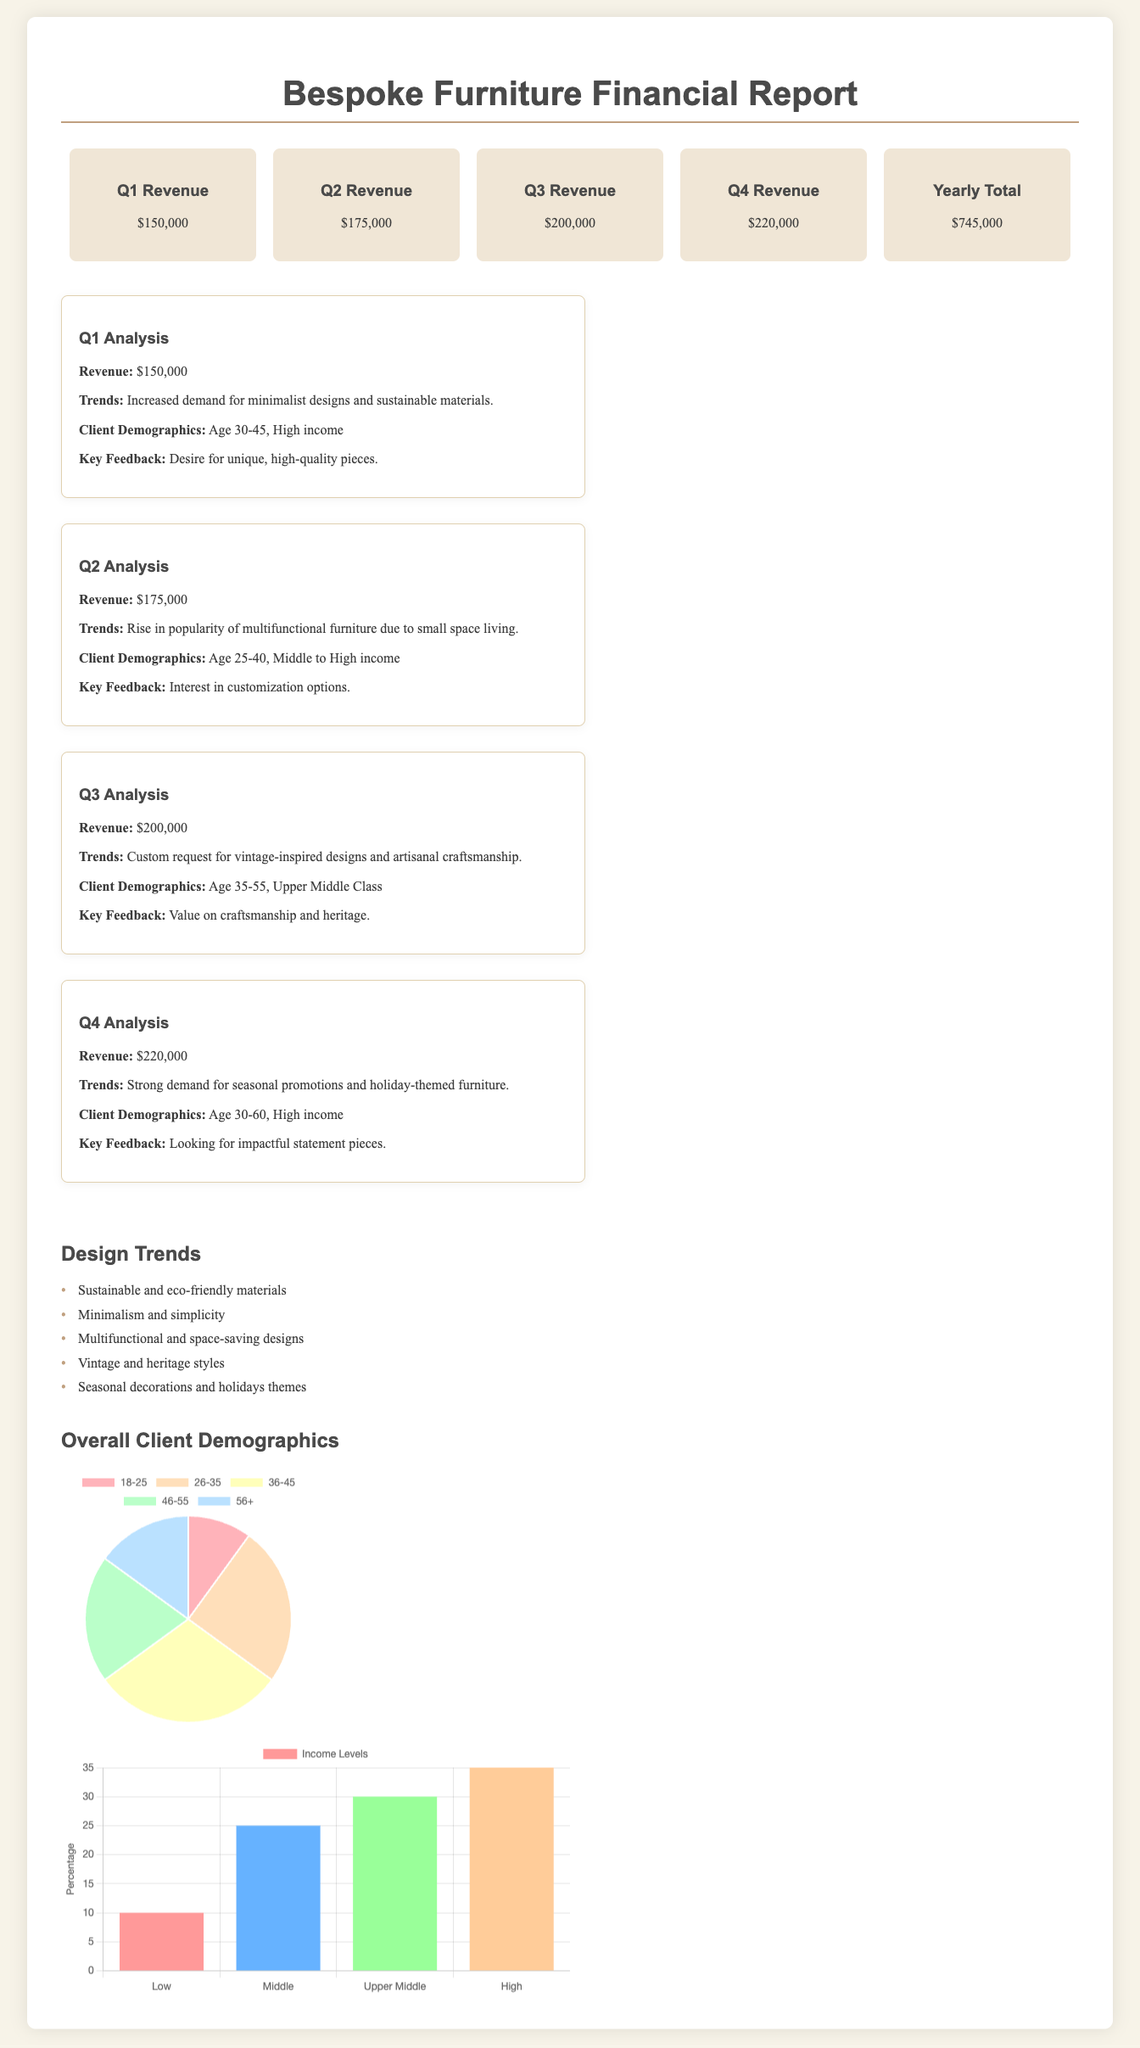What was the revenue in Q3? The revenue for Q3 is specifically mentioned in the quarterly analysis section of the document.
Answer: $200,000 What trend was noted in Q1? The trend for Q1 highlights a specific shift in consumer preferences as detailed in the quarterly analysis section.
Answer: Increased demand for minimalist designs and sustainable materials What is the total annual revenue reported? The total yearly revenue is calculated by summing the revenues from all four quarters, as stated in the overview.
Answer: $745,000 What age group makes up the highest percentage of clients? The demographics section includes an age distribution chart that reveals which age group has the largest representation among clients.
Answer: Age 36-45 What theme was popular in Q4? The quarterly analysis for Q4 specifies a trend that captures seasonal market demand as outlined.
Answer: Seasonal promotions and holiday-themed furniture Which income demographic had the least representation? The income levels chart displays the distribution of clients, allowing us to discern which category has the lowest percentage.
Answer: Low What is the trend for Q2? The quarterly analysis section describes a specific trend that was prevalent during the second quarter, indicating changes in client needs.
Answer: Rise in popularity of multifunctional furniture due to small space living What percentage of clients are in the Upper Middle income group? The income levels chart lists percentages for each income category, from which the specific figure for Upper Middle can be directly referenced.
Answer: 30% 